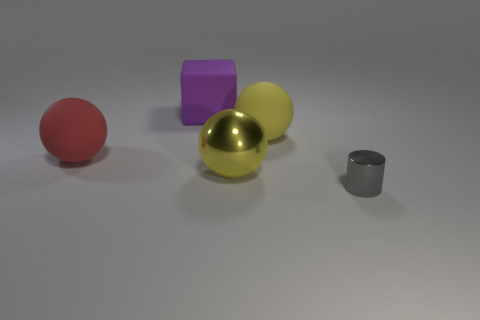There is a purple object that is the same size as the red ball; what is its shape?
Provide a succinct answer. Cube. What number of objects are either tiny gray cylinders in front of the big metal object or big yellow objects that are behind the big yellow metallic thing?
Make the answer very short. 2. What material is the yellow object that is the same size as the yellow matte sphere?
Give a very brief answer. Metal. What number of other things are the same material as the tiny gray thing?
Give a very brief answer. 1. Is the number of large yellow metallic spheres right of the tiny gray shiny cylinder the same as the number of red matte balls that are to the left of the yellow rubber thing?
Your answer should be very brief. No. How many green things are either large matte cubes or large things?
Make the answer very short. 0. There is a large shiny object; is it the same color as the big object that is right of the big yellow metal sphere?
Offer a terse response. Yes. What number of other objects are there of the same color as the tiny shiny cylinder?
Your response must be concise. 0. Are there fewer small red rubber things than big spheres?
Offer a terse response. Yes. There is a metal thing that is on the right side of the big yellow thing that is behind the large shiny sphere; how many purple things are right of it?
Your response must be concise. 0. 